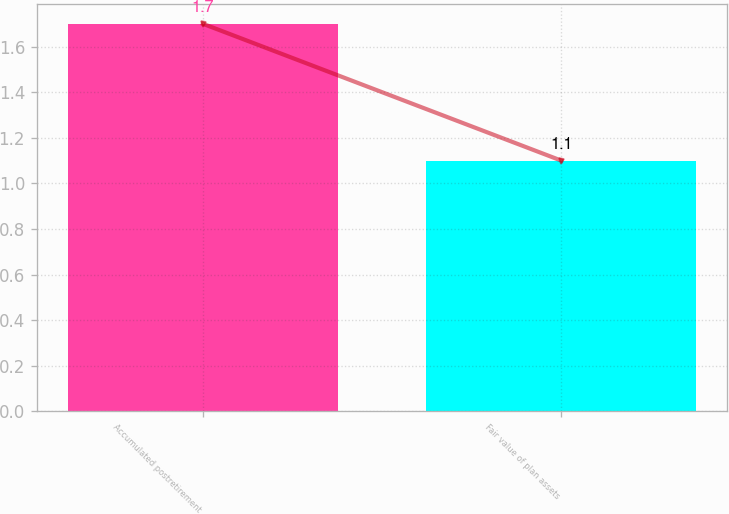<chart> <loc_0><loc_0><loc_500><loc_500><bar_chart><fcel>Accumulated postretirement<fcel>Fair value of plan assets<nl><fcel>1.7<fcel>1.1<nl></chart> 